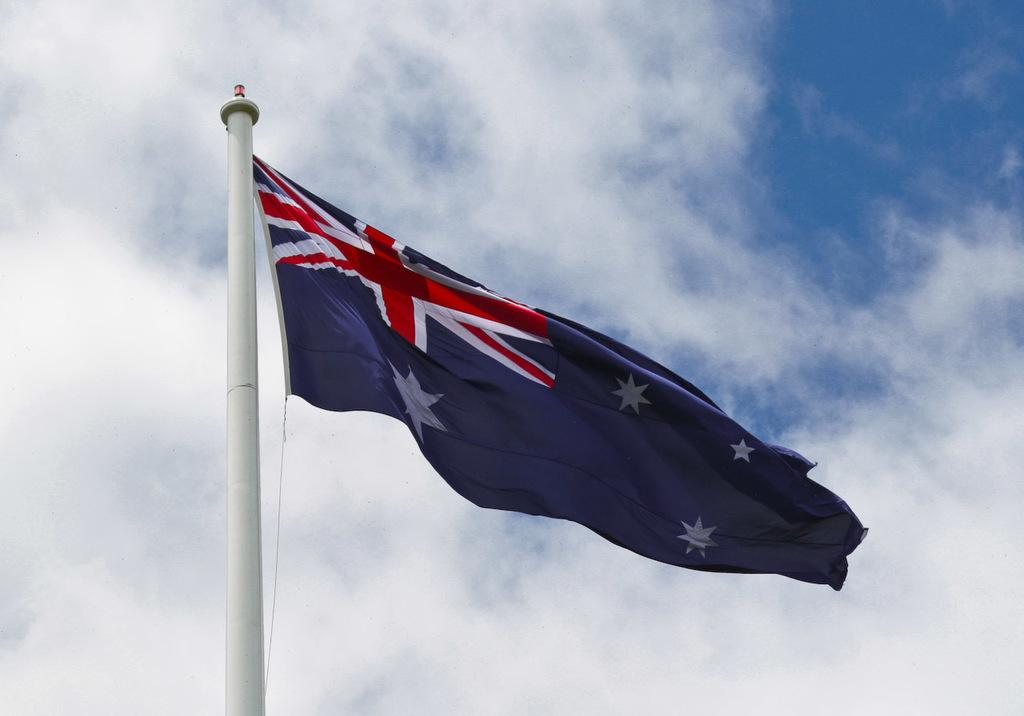What is the main object in the image? There is a white color pole in the image. What is attached to the pole? A flag is present on the pole. What colors are on the flag? The flag has white, blue, and red colors. What can be seen in the background of the image? The sky is visible in the background of the image. What is the condition of the sky in the image? The sky is clear in the image. How many leather shoes can be seen falling from the sky in the image? There are no leather shoes falling from the sky in the image. Is there a parent holding the hand of a child in the image? There is no parent or child present in the image. 